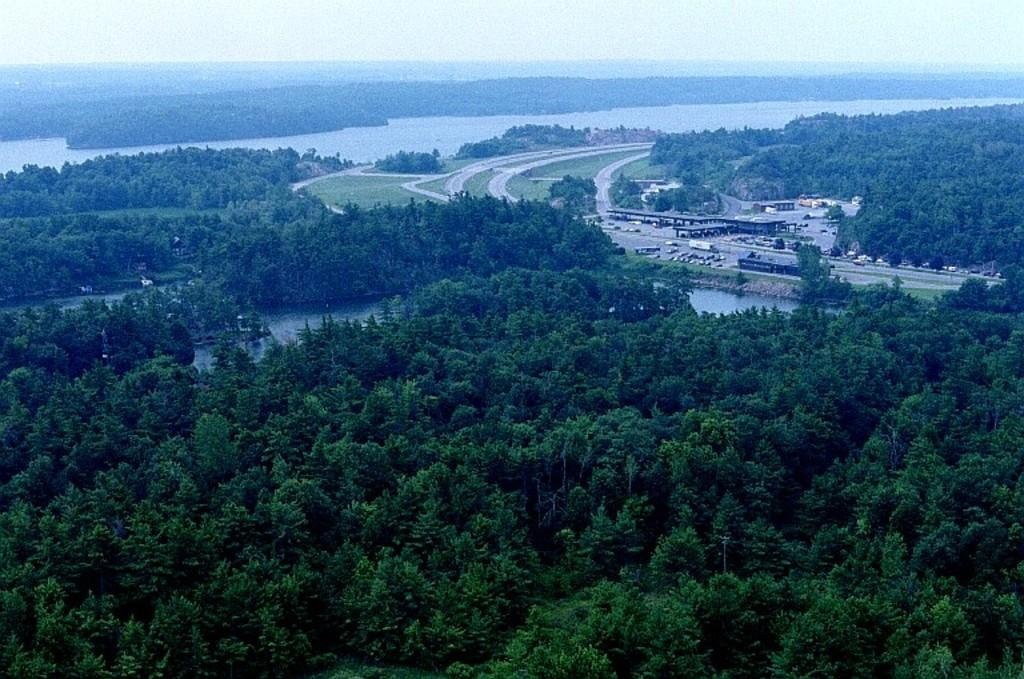What type of natural environment is depicted in the image? There are many trees in the image, indicating a natural environment. What type of man-made structures can be seen in the image? There are roads with vehicles in the image, suggesting the presence of man-made structures. What type of water is visible in the image? There is water visible in the image, but the specific type of water (e.g., river, lake, ocean) cannot be determined from the provided facts. What is visible at the top of the image? The sky is visible at the top of the image. What type of hammer is being used to play a question in the image? There is no hammer, playing, or question present in the image. 